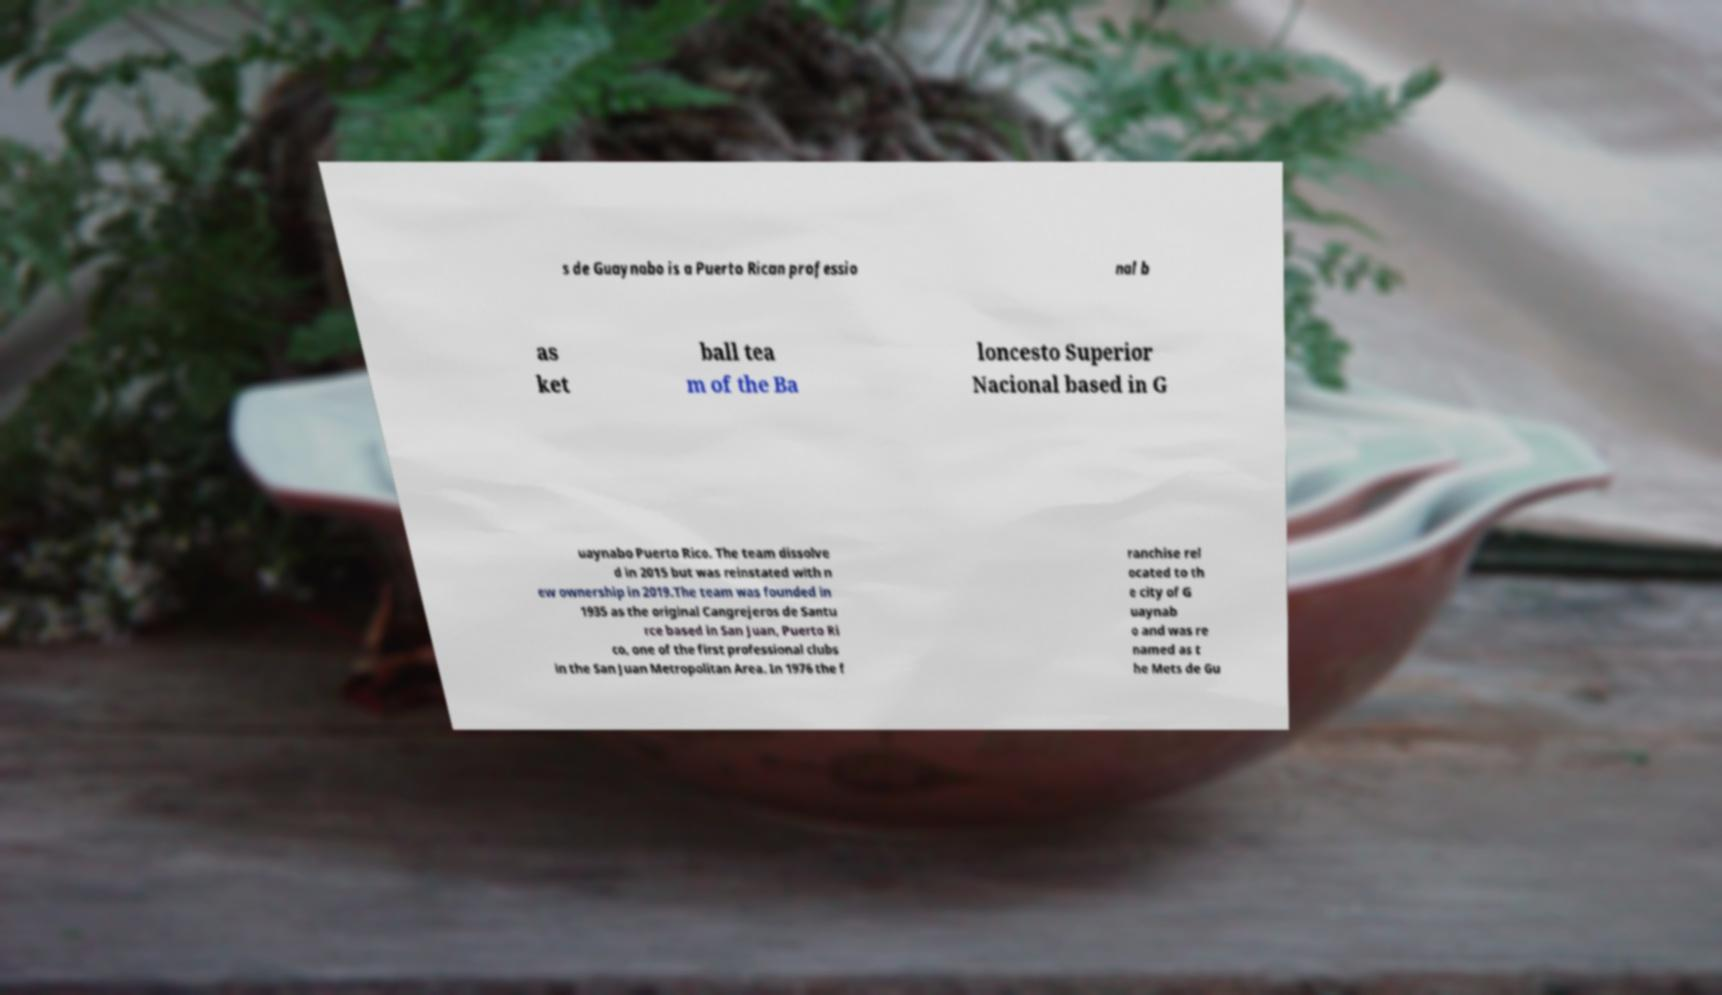Please read and relay the text visible in this image. What does it say? s de Guaynabo is a Puerto Rican professio nal b as ket ball tea m of the Ba loncesto Superior Nacional based in G uaynabo Puerto Rico. The team dissolve d in 2015 but was reinstated with n ew ownership in 2019.The team was founded in 1935 as the original Cangrejeros de Santu rce based in San Juan, Puerto Ri co, one of the first professional clubs in the San Juan Metropolitan Area. In 1976 the f ranchise rel ocated to th e city of G uaynab o and was re named as t he Mets de Gu 